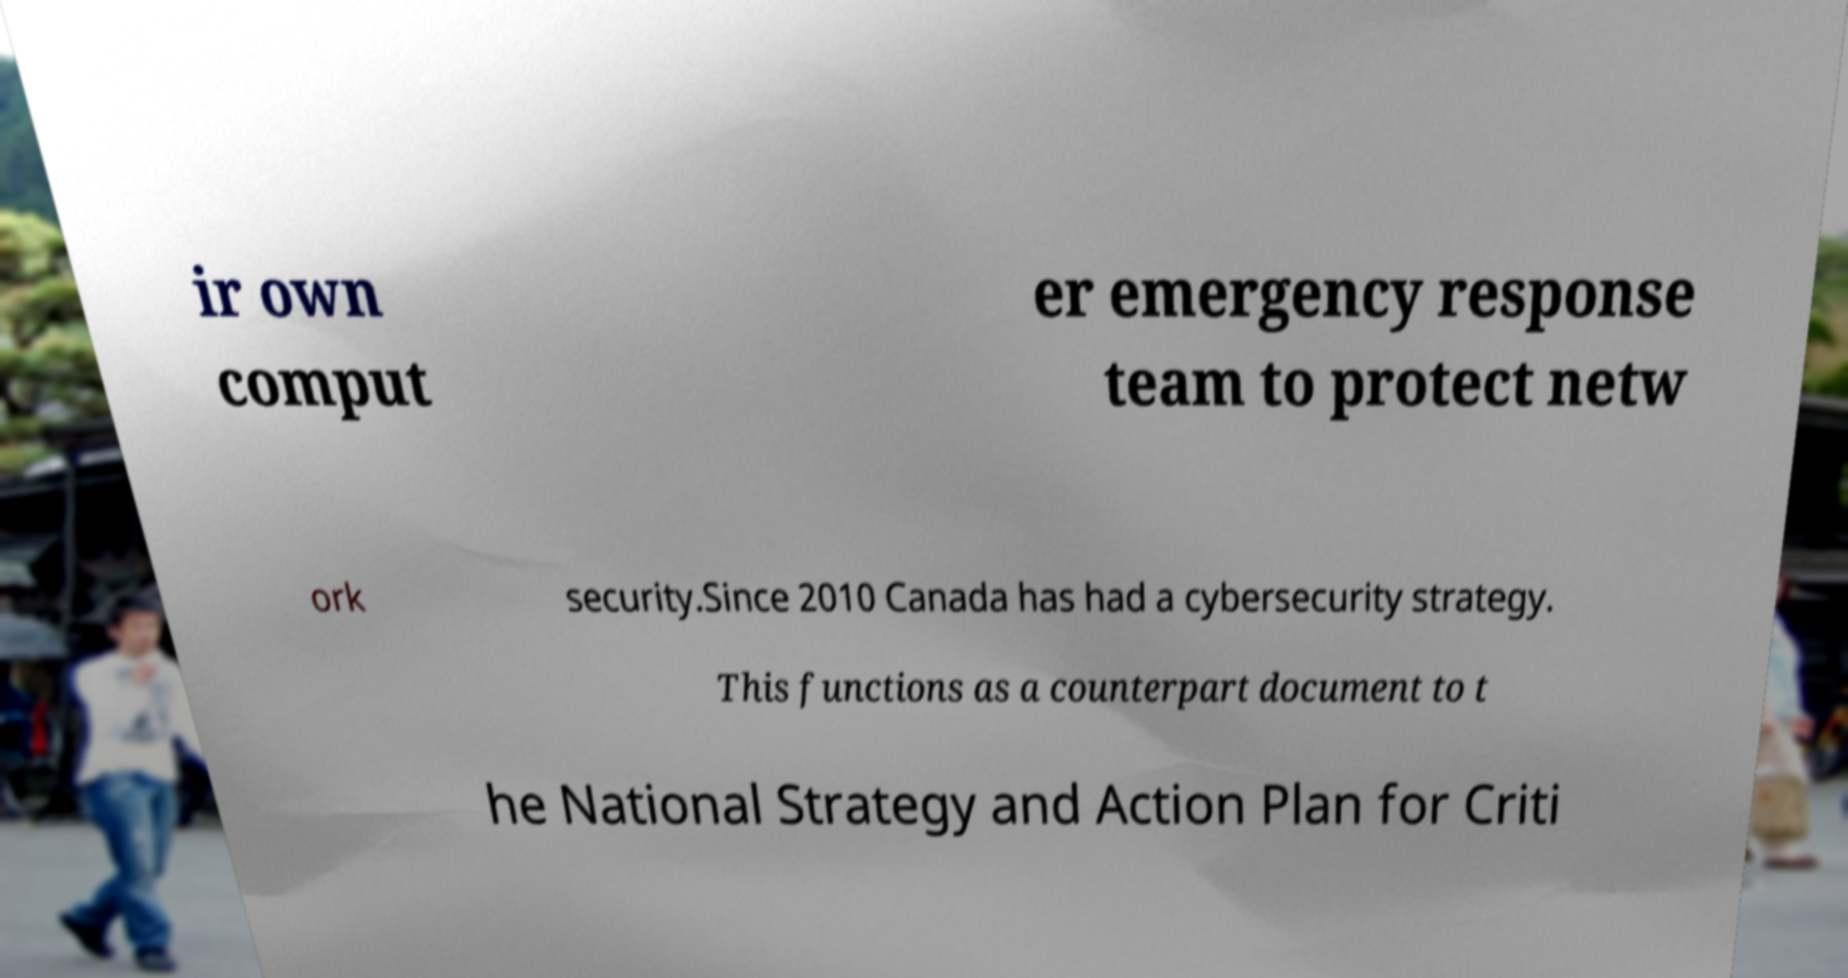Could you assist in decoding the text presented in this image and type it out clearly? ir own comput er emergency response team to protect netw ork security.Since 2010 Canada has had a cybersecurity strategy. This functions as a counterpart document to t he National Strategy and Action Plan for Criti 